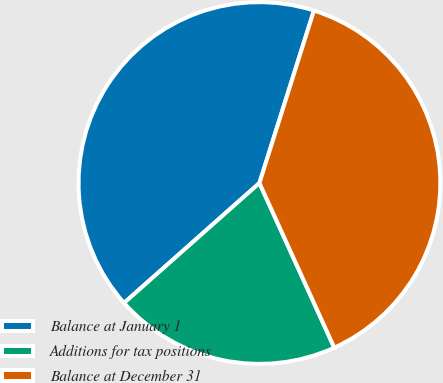<chart> <loc_0><loc_0><loc_500><loc_500><pie_chart><fcel>Balance at January 1<fcel>Additions for tax positions<fcel>Balance at December 31<nl><fcel>41.41%<fcel>20.25%<fcel>38.34%<nl></chart> 